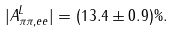Convert formula to latex. <formula><loc_0><loc_0><loc_500><loc_500>| A ^ { L } _ { \pi \pi , e e } | = ( 1 3 . 4 \pm 0 . 9 ) \% .</formula> 